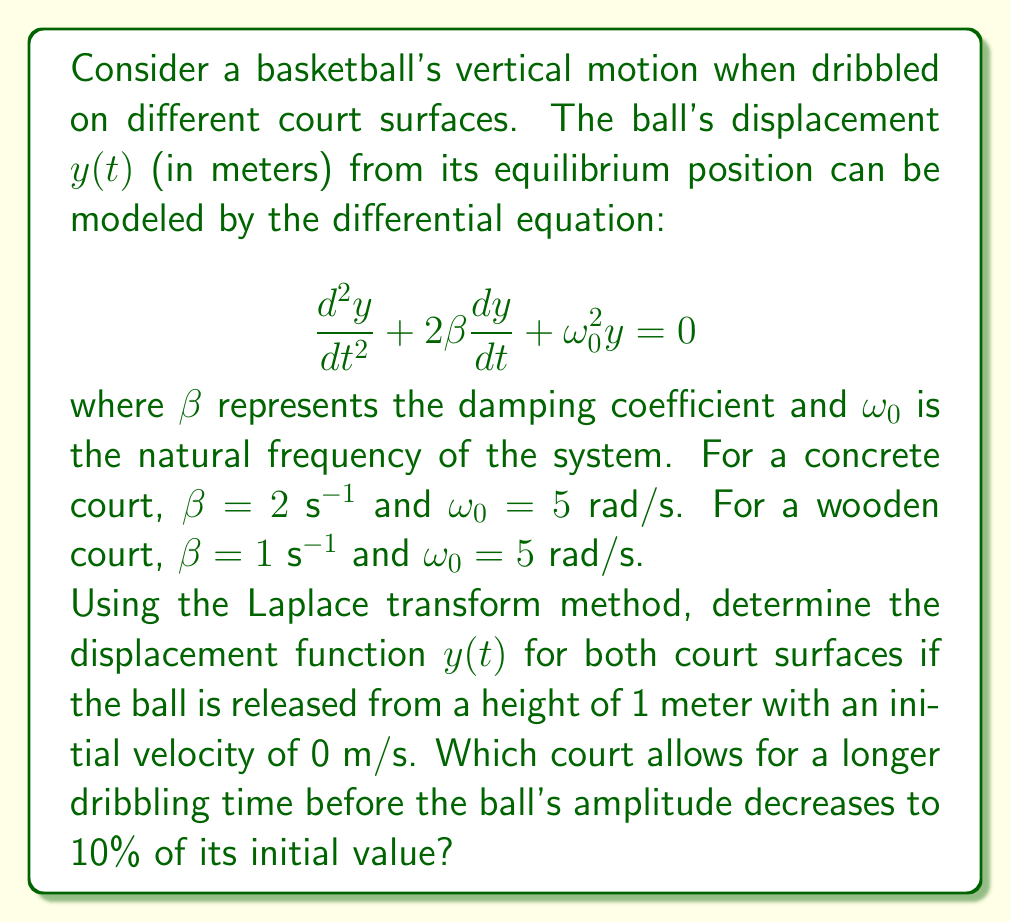Solve this math problem. Let's solve this problem step by step using the Laplace transform method:

1) The Laplace transform of the differential equation is:

   $$s^2Y(s) - sy(0) - y'(0) + 2\beta(sY(s) - y(0)) + \omega_0^2Y(s) = 0$$

2) Given initial conditions: $y(0) = 1$ and $y'(0) = 0$

3) Substituting these conditions:

   $$s^2Y(s) - s + 2\beta(sY(s) - 1) + \omega_0^2Y(s) = 0$$

4) Solving for $Y(s)$:

   $$Y(s) = \frac{s + 2\beta}{s^2 + 2\beta s + \omega_0^2}$$

5) For the concrete court ($\beta = 2$, $\omega_0 = 5$):

   $$Y_c(s) = \frac{s + 4}{s^2 + 4s + 25}$$

6) For the wooden court ($\beta = 1$, $\omega_0 = 5$):

   $$Y_w(s) = \frac{s + 2}{s^2 + 2s + 25}$$

7) To find $y(t)$, we need to find the inverse Laplace transform. The general form is:

   $$y(t) = e^{-\beta t}(A\cos(\omega_d t) + B\sin(\omega_d t))$$

   where $\omega_d = \sqrt{\omega_0^2 - \beta^2}$

8) For the concrete court:
   $\omega_d = \sqrt{25 - 4} = \sqrt{21}$
   
   $$y_c(t) = e^{-2t}(\cos(\sqrt{21}t) + \frac{2}{\sqrt{21}}\sin(\sqrt{21}t))$$

9) For the wooden court:
   $\omega_d = \sqrt{25 - 1} = 2\sqrt{6}$
   
   $$y_w(t) = e^{-t}(\cos(2\sqrt{6}t) + \frac{1}{2\sqrt{6}}\sin(2\sqrt{6}t))$$

10) To find when the amplitude decreases to 10% of its initial value, we need to solve:

    $$e^{-\beta t} = 0.1$$

    $$t = -\frac{\ln(0.1)}{\beta} = \frac{2.3}{\beta}$$

11) For the concrete court: $t_c = \frac{2.3}{2} = 1.15$ seconds
    For the wooden court: $t_w = \frac{2.3}{1} = 2.3$ seconds

Therefore, the wooden court allows for a longer dribbling time before the ball's amplitude decreases to 10% of its initial value.
Answer: The displacement functions are:

Concrete court: $y_c(t) = e^{-2t}(\cos(\sqrt{21}t) + \frac{2}{\sqrt{21}}\sin(\sqrt{21}t))$

Wooden court: $y_w(t) = e^{-t}(\cos(2\sqrt{6}t) + \frac{1}{2\sqrt{6}}\sin(2\sqrt{6}t))$

The wooden court allows for a longer dribbling time of 2.3 seconds before the ball's amplitude decreases to 10% of its initial value, compared to 1.15 seconds for the concrete court. 